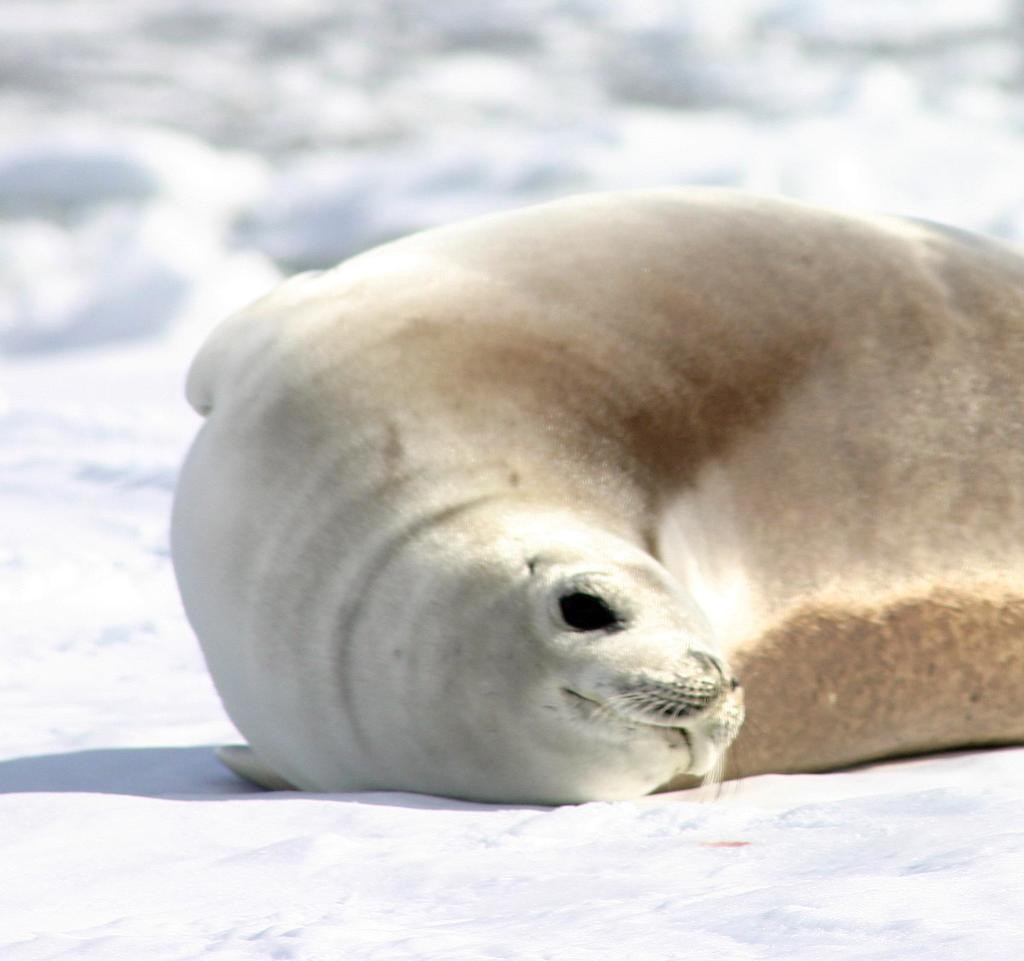What type of animal is in the image? There is a harbor seal in the image. What is the position of the harbor seal in the image? The harbor seal appears to be lying on the ground. What type of environment is depicted in the image? There is a lot of snow visible in the image. What type of hat is the harbor seal wearing in the image? There is no hat present in the image; the harbor seal is not wearing any clothing or accessories. 